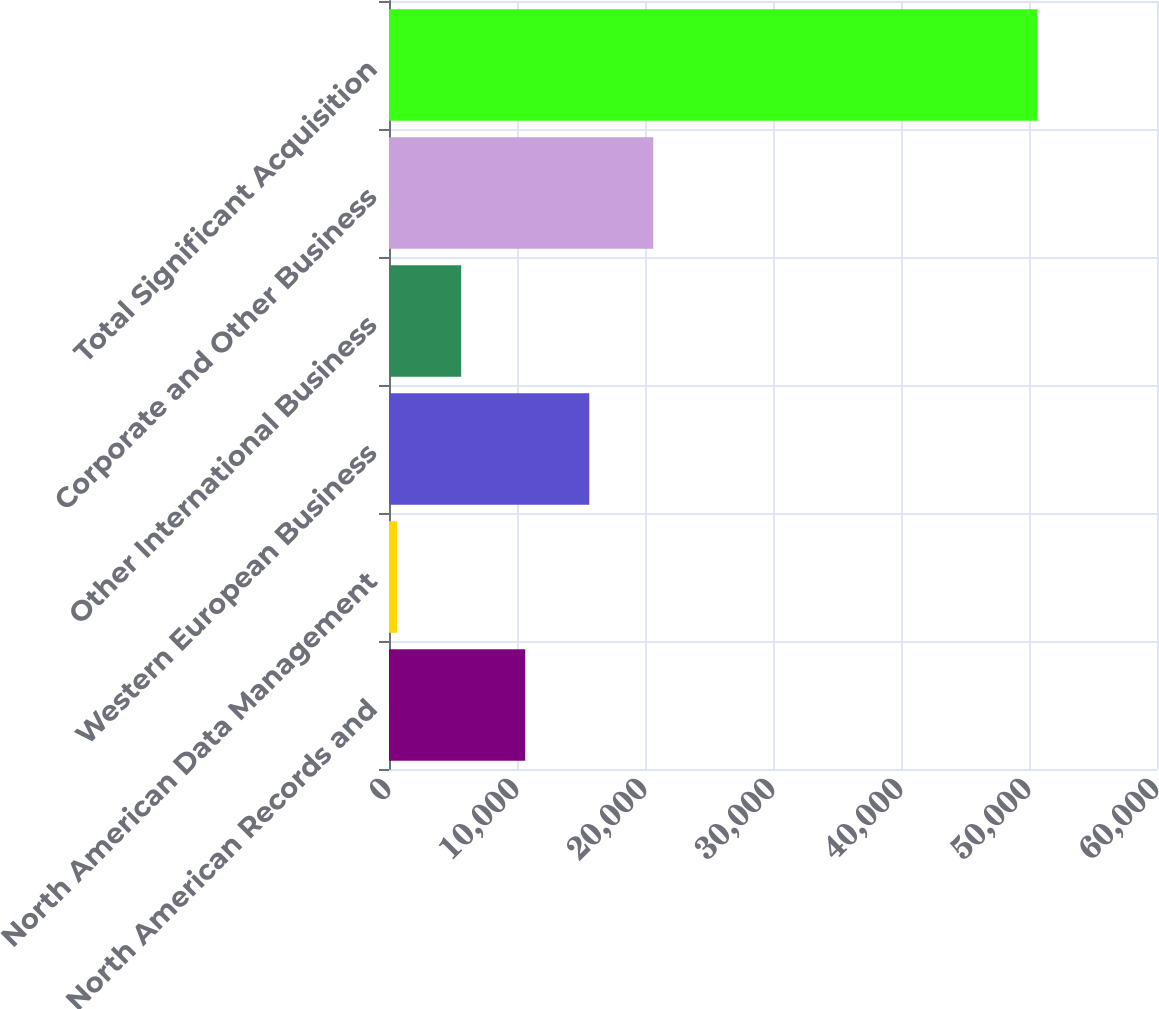Convert chart to OTSL. <chart><loc_0><loc_0><loc_500><loc_500><bar_chart><fcel>North American Records and<fcel>North American Data Management<fcel>Western European Business<fcel>Other International Business<fcel>Corporate and Other Business<fcel>Total Significant Acquisition<nl><fcel>10642.6<fcel>637<fcel>15645.4<fcel>5639.8<fcel>20648.2<fcel>50665<nl></chart> 